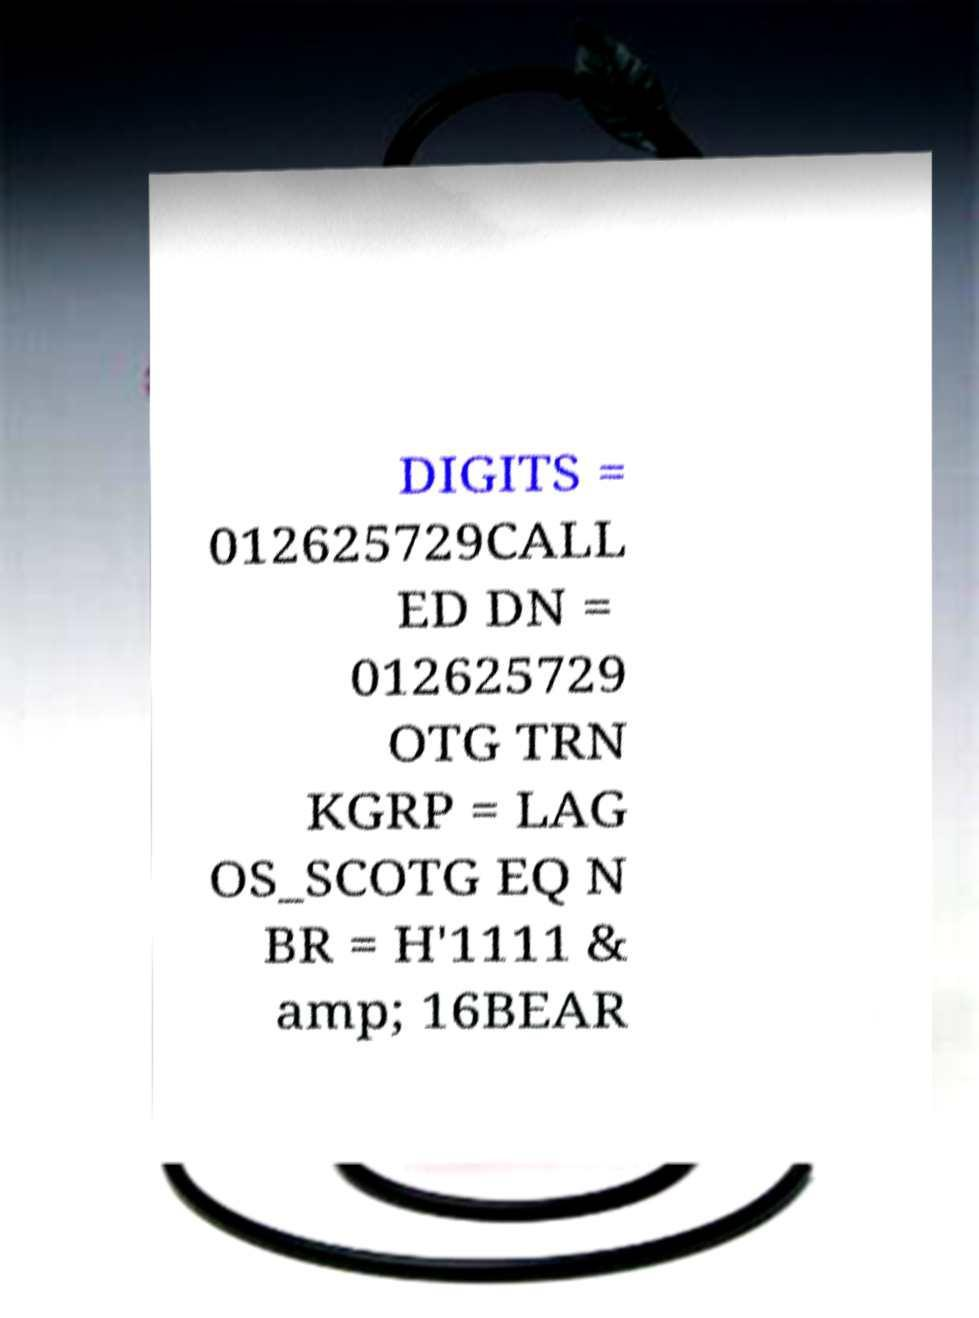I need the written content from this picture converted into text. Can you do that? DIGITS = 012625729CALL ED DN = 012625729 OTG TRN KGRP = LAG OS_SCOTG EQ N BR = H'1111 & amp; 16BEAR 